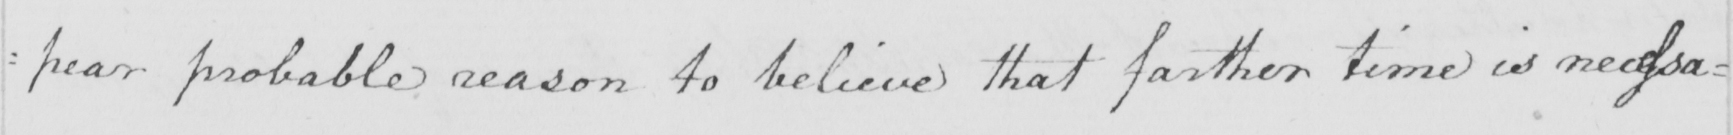Can you read and transcribe this handwriting? : pear probable reason to believe that farther time is necessa= 